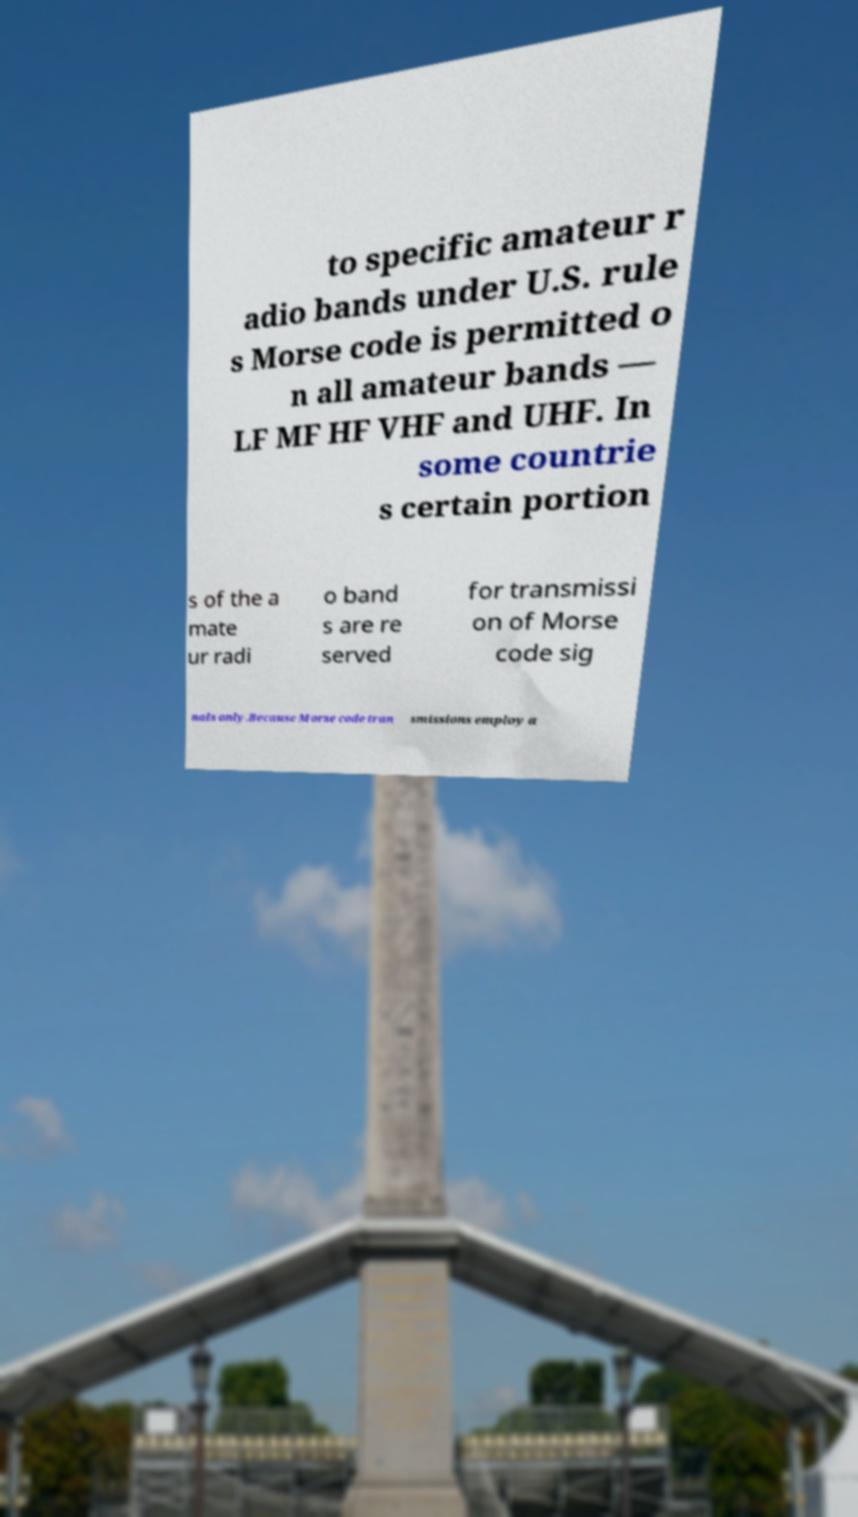For documentation purposes, I need the text within this image transcribed. Could you provide that? to specific amateur r adio bands under U.S. rule s Morse code is permitted o n all amateur bands — LF MF HF VHF and UHF. In some countrie s certain portion s of the a mate ur radi o band s are re served for transmissi on of Morse code sig nals only.Because Morse code tran smissions employ a 